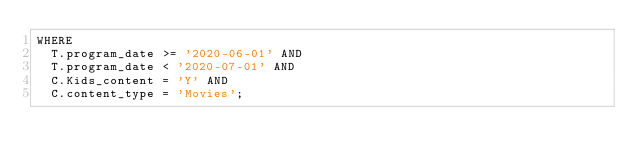Convert code to text. <code><loc_0><loc_0><loc_500><loc_500><_SQL_>WHERE 
  T.program_date >= '2020-06-01' AND
  T.program_date < '2020-07-01' AND
  C.Kids_content = 'Y' AND
  C.content_type = 'Movies';
</code> 